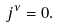Convert formula to latex. <formula><loc_0><loc_0><loc_500><loc_500>j ^ { \nu } = 0 .</formula> 